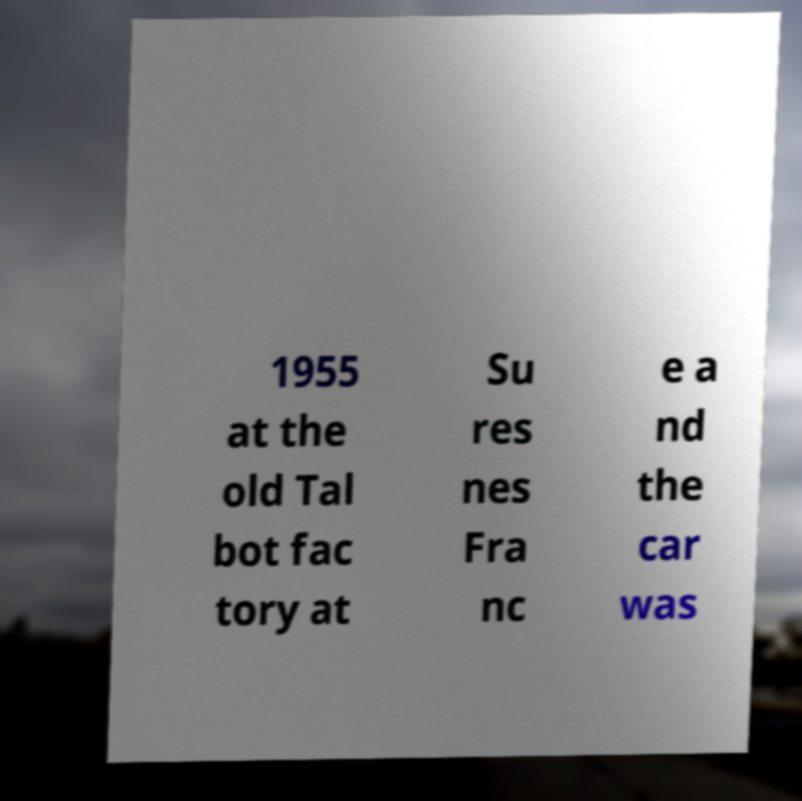Could you extract and type out the text from this image? 1955 at the old Tal bot fac tory at Su res nes Fra nc e a nd the car was 